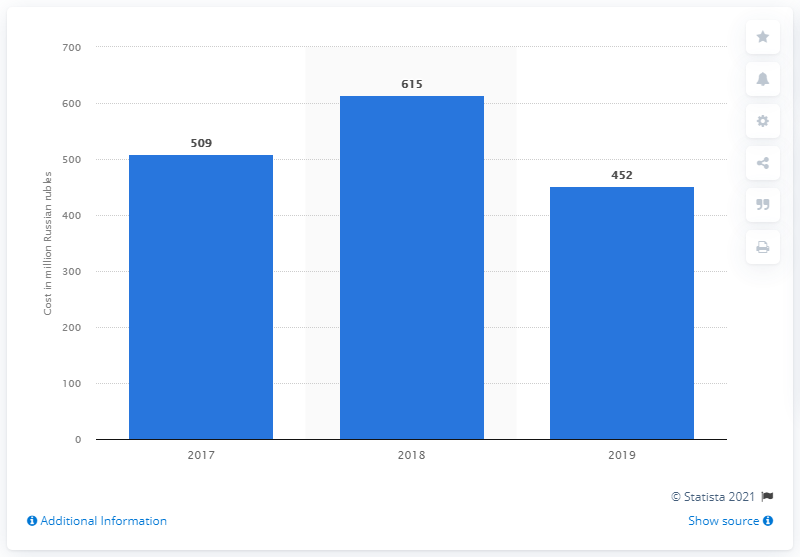Specify some key components in this picture. In 2019, the Victory Day festivities cost 452 Russian rubles. 